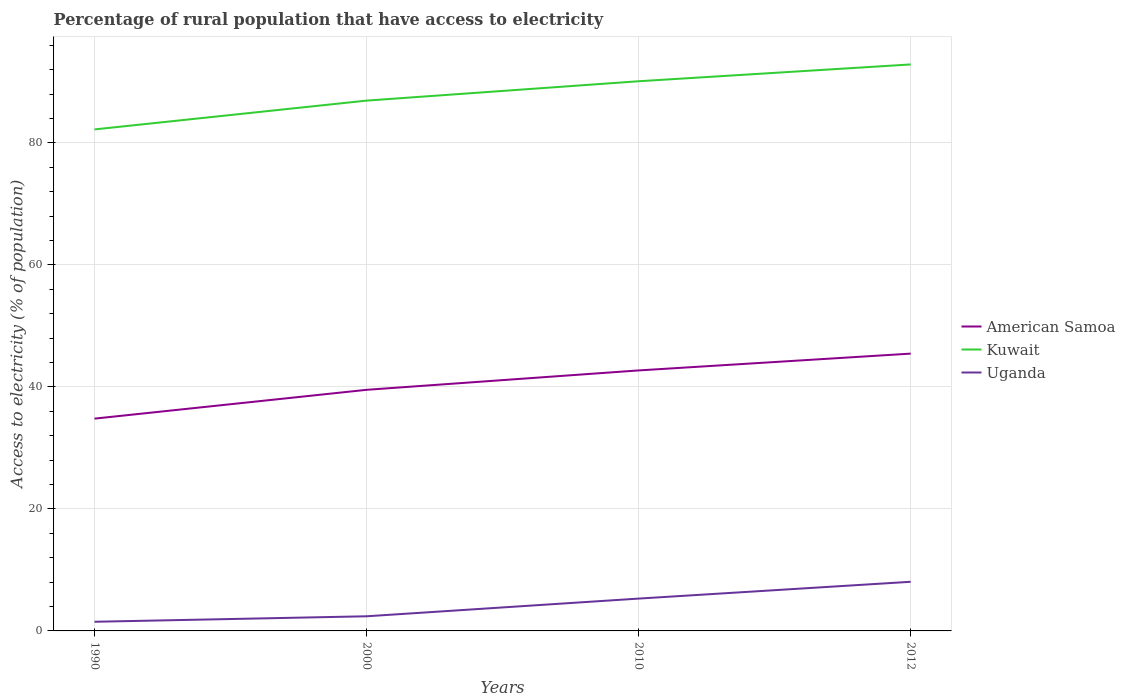How many different coloured lines are there?
Provide a short and direct response. 3. Does the line corresponding to Kuwait intersect with the line corresponding to Uganda?
Your response must be concise. No. Across all years, what is the maximum percentage of rural population that have access to electricity in Kuwait?
Ensure brevity in your answer.  82.2. What is the total percentage of rural population that have access to electricity in Uganda in the graph?
Your response must be concise. -0.9. What is the difference between the highest and the second highest percentage of rural population that have access to electricity in Kuwait?
Make the answer very short. 10.65. Is the percentage of rural population that have access to electricity in Uganda strictly greater than the percentage of rural population that have access to electricity in Kuwait over the years?
Give a very brief answer. Yes. What is the difference between two consecutive major ticks on the Y-axis?
Offer a terse response. 20. Are the values on the major ticks of Y-axis written in scientific E-notation?
Your answer should be very brief. No. Does the graph contain grids?
Your answer should be very brief. Yes. What is the title of the graph?
Offer a very short reply. Percentage of rural population that have access to electricity. What is the label or title of the X-axis?
Make the answer very short. Years. What is the label or title of the Y-axis?
Your response must be concise. Access to electricity (% of population). What is the Access to electricity (% of population) in American Samoa in 1990?
Provide a succinct answer. 34.8. What is the Access to electricity (% of population) of Kuwait in 1990?
Offer a very short reply. 82.2. What is the Access to electricity (% of population) of American Samoa in 2000?
Provide a succinct answer. 39.52. What is the Access to electricity (% of population) of Kuwait in 2000?
Your response must be concise. 86.93. What is the Access to electricity (% of population) of Uganda in 2000?
Offer a very short reply. 2.4. What is the Access to electricity (% of population) of American Samoa in 2010?
Keep it short and to the point. 42.7. What is the Access to electricity (% of population) in Kuwait in 2010?
Make the answer very short. 90.1. What is the Access to electricity (% of population) of Uganda in 2010?
Keep it short and to the point. 5.3. What is the Access to electricity (% of population) of American Samoa in 2012?
Offer a very short reply. 45.45. What is the Access to electricity (% of population) of Kuwait in 2012?
Your response must be concise. 92.85. What is the Access to electricity (% of population) of Uganda in 2012?
Provide a succinct answer. 8.05. Across all years, what is the maximum Access to electricity (% of population) of American Samoa?
Your answer should be compact. 45.45. Across all years, what is the maximum Access to electricity (% of population) in Kuwait?
Ensure brevity in your answer.  92.85. Across all years, what is the maximum Access to electricity (% of population) in Uganda?
Ensure brevity in your answer.  8.05. Across all years, what is the minimum Access to electricity (% of population) in American Samoa?
Offer a terse response. 34.8. Across all years, what is the minimum Access to electricity (% of population) of Kuwait?
Offer a very short reply. 82.2. What is the total Access to electricity (% of population) of American Samoa in the graph?
Give a very brief answer. 162.47. What is the total Access to electricity (% of population) of Kuwait in the graph?
Provide a succinct answer. 352.08. What is the total Access to electricity (% of population) in Uganda in the graph?
Offer a very short reply. 17.25. What is the difference between the Access to electricity (% of population) of American Samoa in 1990 and that in 2000?
Make the answer very short. -4.72. What is the difference between the Access to electricity (% of population) of Kuwait in 1990 and that in 2000?
Your answer should be compact. -4.72. What is the difference between the Access to electricity (% of population) of American Samoa in 1990 and that in 2010?
Make the answer very short. -7.9. What is the difference between the Access to electricity (% of population) of Kuwait in 1990 and that in 2010?
Offer a terse response. -7.9. What is the difference between the Access to electricity (% of population) of American Samoa in 1990 and that in 2012?
Your answer should be very brief. -10.66. What is the difference between the Access to electricity (% of population) in Kuwait in 1990 and that in 2012?
Give a very brief answer. -10.65. What is the difference between the Access to electricity (% of population) of Uganda in 1990 and that in 2012?
Offer a terse response. -6.55. What is the difference between the Access to electricity (% of population) of American Samoa in 2000 and that in 2010?
Ensure brevity in your answer.  -3.18. What is the difference between the Access to electricity (% of population) of Kuwait in 2000 and that in 2010?
Keep it short and to the point. -3.17. What is the difference between the Access to electricity (% of population) of Uganda in 2000 and that in 2010?
Keep it short and to the point. -2.9. What is the difference between the Access to electricity (% of population) in American Samoa in 2000 and that in 2012?
Offer a very short reply. -5.93. What is the difference between the Access to electricity (% of population) in Kuwait in 2000 and that in 2012?
Your answer should be very brief. -5.93. What is the difference between the Access to electricity (% of population) in Uganda in 2000 and that in 2012?
Provide a short and direct response. -5.65. What is the difference between the Access to electricity (% of population) of American Samoa in 2010 and that in 2012?
Provide a short and direct response. -2.75. What is the difference between the Access to electricity (% of population) in Kuwait in 2010 and that in 2012?
Your answer should be compact. -2.75. What is the difference between the Access to electricity (% of population) in Uganda in 2010 and that in 2012?
Make the answer very short. -2.75. What is the difference between the Access to electricity (% of population) in American Samoa in 1990 and the Access to electricity (% of population) in Kuwait in 2000?
Your answer should be compact. -52.13. What is the difference between the Access to electricity (% of population) in American Samoa in 1990 and the Access to electricity (% of population) in Uganda in 2000?
Give a very brief answer. 32.4. What is the difference between the Access to electricity (% of population) in Kuwait in 1990 and the Access to electricity (% of population) in Uganda in 2000?
Your response must be concise. 79.8. What is the difference between the Access to electricity (% of population) in American Samoa in 1990 and the Access to electricity (% of population) in Kuwait in 2010?
Ensure brevity in your answer.  -55.3. What is the difference between the Access to electricity (% of population) of American Samoa in 1990 and the Access to electricity (% of population) of Uganda in 2010?
Offer a very short reply. 29.5. What is the difference between the Access to electricity (% of population) in Kuwait in 1990 and the Access to electricity (% of population) in Uganda in 2010?
Make the answer very short. 76.9. What is the difference between the Access to electricity (% of population) in American Samoa in 1990 and the Access to electricity (% of population) in Kuwait in 2012?
Your response must be concise. -58.06. What is the difference between the Access to electricity (% of population) of American Samoa in 1990 and the Access to electricity (% of population) of Uganda in 2012?
Offer a very short reply. 26.74. What is the difference between the Access to electricity (% of population) in Kuwait in 1990 and the Access to electricity (% of population) in Uganda in 2012?
Your response must be concise. 74.15. What is the difference between the Access to electricity (% of population) in American Samoa in 2000 and the Access to electricity (% of population) in Kuwait in 2010?
Provide a succinct answer. -50.58. What is the difference between the Access to electricity (% of population) in American Samoa in 2000 and the Access to electricity (% of population) in Uganda in 2010?
Offer a terse response. 34.22. What is the difference between the Access to electricity (% of population) of Kuwait in 2000 and the Access to electricity (% of population) of Uganda in 2010?
Ensure brevity in your answer.  81.63. What is the difference between the Access to electricity (% of population) of American Samoa in 2000 and the Access to electricity (% of population) of Kuwait in 2012?
Provide a short and direct response. -53.33. What is the difference between the Access to electricity (% of population) in American Samoa in 2000 and the Access to electricity (% of population) in Uganda in 2012?
Offer a terse response. 31.47. What is the difference between the Access to electricity (% of population) in Kuwait in 2000 and the Access to electricity (% of population) in Uganda in 2012?
Ensure brevity in your answer.  78.87. What is the difference between the Access to electricity (% of population) in American Samoa in 2010 and the Access to electricity (% of population) in Kuwait in 2012?
Your answer should be compact. -50.15. What is the difference between the Access to electricity (% of population) of American Samoa in 2010 and the Access to electricity (% of population) of Uganda in 2012?
Your answer should be very brief. 34.65. What is the difference between the Access to electricity (% of population) of Kuwait in 2010 and the Access to electricity (% of population) of Uganda in 2012?
Provide a short and direct response. 82.05. What is the average Access to electricity (% of population) of American Samoa per year?
Provide a succinct answer. 40.62. What is the average Access to electricity (% of population) in Kuwait per year?
Offer a terse response. 88.02. What is the average Access to electricity (% of population) in Uganda per year?
Give a very brief answer. 4.31. In the year 1990, what is the difference between the Access to electricity (% of population) of American Samoa and Access to electricity (% of population) of Kuwait?
Give a very brief answer. -47.41. In the year 1990, what is the difference between the Access to electricity (% of population) in American Samoa and Access to electricity (% of population) in Uganda?
Offer a terse response. 33.3. In the year 1990, what is the difference between the Access to electricity (% of population) of Kuwait and Access to electricity (% of population) of Uganda?
Provide a succinct answer. 80.7. In the year 2000, what is the difference between the Access to electricity (% of population) of American Samoa and Access to electricity (% of population) of Kuwait?
Offer a very short reply. -47.41. In the year 2000, what is the difference between the Access to electricity (% of population) of American Samoa and Access to electricity (% of population) of Uganda?
Offer a terse response. 37.12. In the year 2000, what is the difference between the Access to electricity (% of population) of Kuwait and Access to electricity (% of population) of Uganda?
Ensure brevity in your answer.  84.53. In the year 2010, what is the difference between the Access to electricity (% of population) in American Samoa and Access to electricity (% of population) in Kuwait?
Your answer should be very brief. -47.4. In the year 2010, what is the difference between the Access to electricity (% of population) of American Samoa and Access to electricity (% of population) of Uganda?
Your answer should be compact. 37.4. In the year 2010, what is the difference between the Access to electricity (% of population) of Kuwait and Access to electricity (% of population) of Uganda?
Keep it short and to the point. 84.8. In the year 2012, what is the difference between the Access to electricity (% of population) in American Samoa and Access to electricity (% of population) in Kuwait?
Offer a very short reply. -47.4. In the year 2012, what is the difference between the Access to electricity (% of population) in American Samoa and Access to electricity (% of population) in Uganda?
Make the answer very short. 37.4. In the year 2012, what is the difference between the Access to electricity (% of population) of Kuwait and Access to electricity (% of population) of Uganda?
Make the answer very short. 84.8. What is the ratio of the Access to electricity (% of population) of American Samoa in 1990 to that in 2000?
Your response must be concise. 0.88. What is the ratio of the Access to electricity (% of population) in Kuwait in 1990 to that in 2000?
Your answer should be compact. 0.95. What is the ratio of the Access to electricity (% of population) in American Samoa in 1990 to that in 2010?
Ensure brevity in your answer.  0.81. What is the ratio of the Access to electricity (% of population) in Kuwait in 1990 to that in 2010?
Offer a very short reply. 0.91. What is the ratio of the Access to electricity (% of population) of Uganda in 1990 to that in 2010?
Your answer should be compact. 0.28. What is the ratio of the Access to electricity (% of population) in American Samoa in 1990 to that in 2012?
Your answer should be very brief. 0.77. What is the ratio of the Access to electricity (% of population) in Kuwait in 1990 to that in 2012?
Your answer should be compact. 0.89. What is the ratio of the Access to electricity (% of population) of Uganda in 1990 to that in 2012?
Ensure brevity in your answer.  0.19. What is the ratio of the Access to electricity (% of population) of American Samoa in 2000 to that in 2010?
Provide a succinct answer. 0.93. What is the ratio of the Access to electricity (% of population) of Kuwait in 2000 to that in 2010?
Offer a very short reply. 0.96. What is the ratio of the Access to electricity (% of population) of Uganda in 2000 to that in 2010?
Make the answer very short. 0.45. What is the ratio of the Access to electricity (% of population) in American Samoa in 2000 to that in 2012?
Make the answer very short. 0.87. What is the ratio of the Access to electricity (% of population) in Kuwait in 2000 to that in 2012?
Your answer should be very brief. 0.94. What is the ratio of the Access to electricity (% of population) in Uganda in 2000 to that in 2012?
Ensure brevity in your answer.  0.3. What is the ratio of the Access to electricity (% of population) in American Samoa in 2010 to that in 2012?
Your response must be concise. 0.94. What is the ratio of the Access to electricity (% of population) of Kuwait in 2010 to that in 2012?
Provide a short and direct response. 0.97. What is the ratio of the Access to electricity (% of population) in Uganda in 2010 to that in 2012?
Make the answer very short. 0.66. What is the difference between the highest and the second highest Access to electricity (% of population) in American Samoa?
Provide a short and direct response. 2.75. What is the difference between the highest and the second highest Access to electricity (% of population) of Kuwait?
Make the answer very short. 2.75. What is the difference between the highest and the second highest Access to electricity (% of population) of Uganda?
Your response must be concise. 2.75. What is the difference between the highest and the lowest Access to electricity (% of population) in American Samoa?
Your answer should be very brief. 10.66. What is the difference between the highest and the lowest Access to electricity (% of population) of Kuwait?
Provide a short and direct response. 10.65. What is the difference between the highest and the lowest Access to electricity (% of population) in Uganda?
Keep it short and to the point. 6.55. 